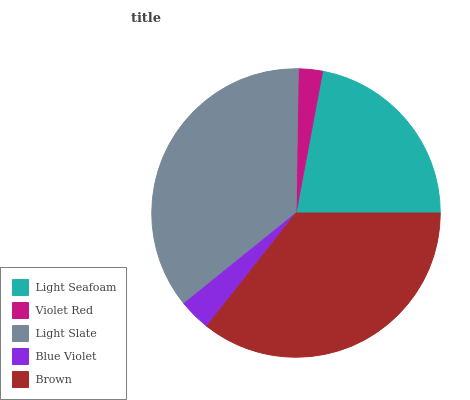Is Violet Red the minimum?
Answer yes or no. Yes. Is Light Slate the maximum?
Answer yes or no. Yes. Is Light Slate the minimum?
Answer yes or no. No. Is Violet Red the maximum?
Answer yes or no. No. Is Light Slate greater than Violet Red?
Answer yes or no. Yes. Is Violet Red less than Light Slate?
Answer yes or no. Yes. Is Violet Red greater than Light Slate?
Answer yes or no. No. Is Light Slate less than Violet Red?
Answer yes or no. No. Is Light Seafoam the high median?
Answer yes or no. Yes. Is Light Seafoam the low median?
Answer yes or no. Yes. Is Violet Red the high median?
Answer yes or no. No. Is Brown the low median?
Answer yes or no. No. 